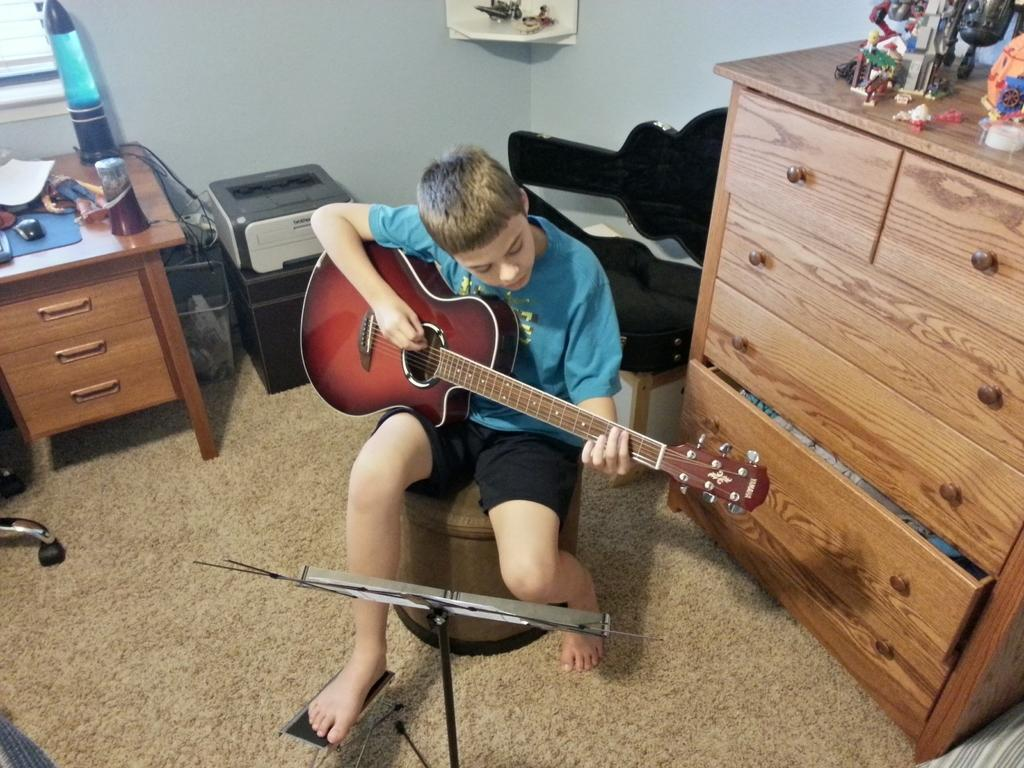What is the person in the image doing? The person is sitting and holding a guitar. What objects can be seen on the table in the image? There is a mouse, a paper, a toy, and a table lamp on the table. What is the person holding in the image? The person is holding a guitar. How many items are on the table in the image? There are five items on the table: a mouse, a paper, a toy, a table lamp, and a guitar. What type of wristwatch can be seen on the person's wrist in the image? There is no wristwatch visible on the person's wrist in the image. How does the toy on the table create friction in the image? The toy does not create friction in the image; it is stationary on the table. 